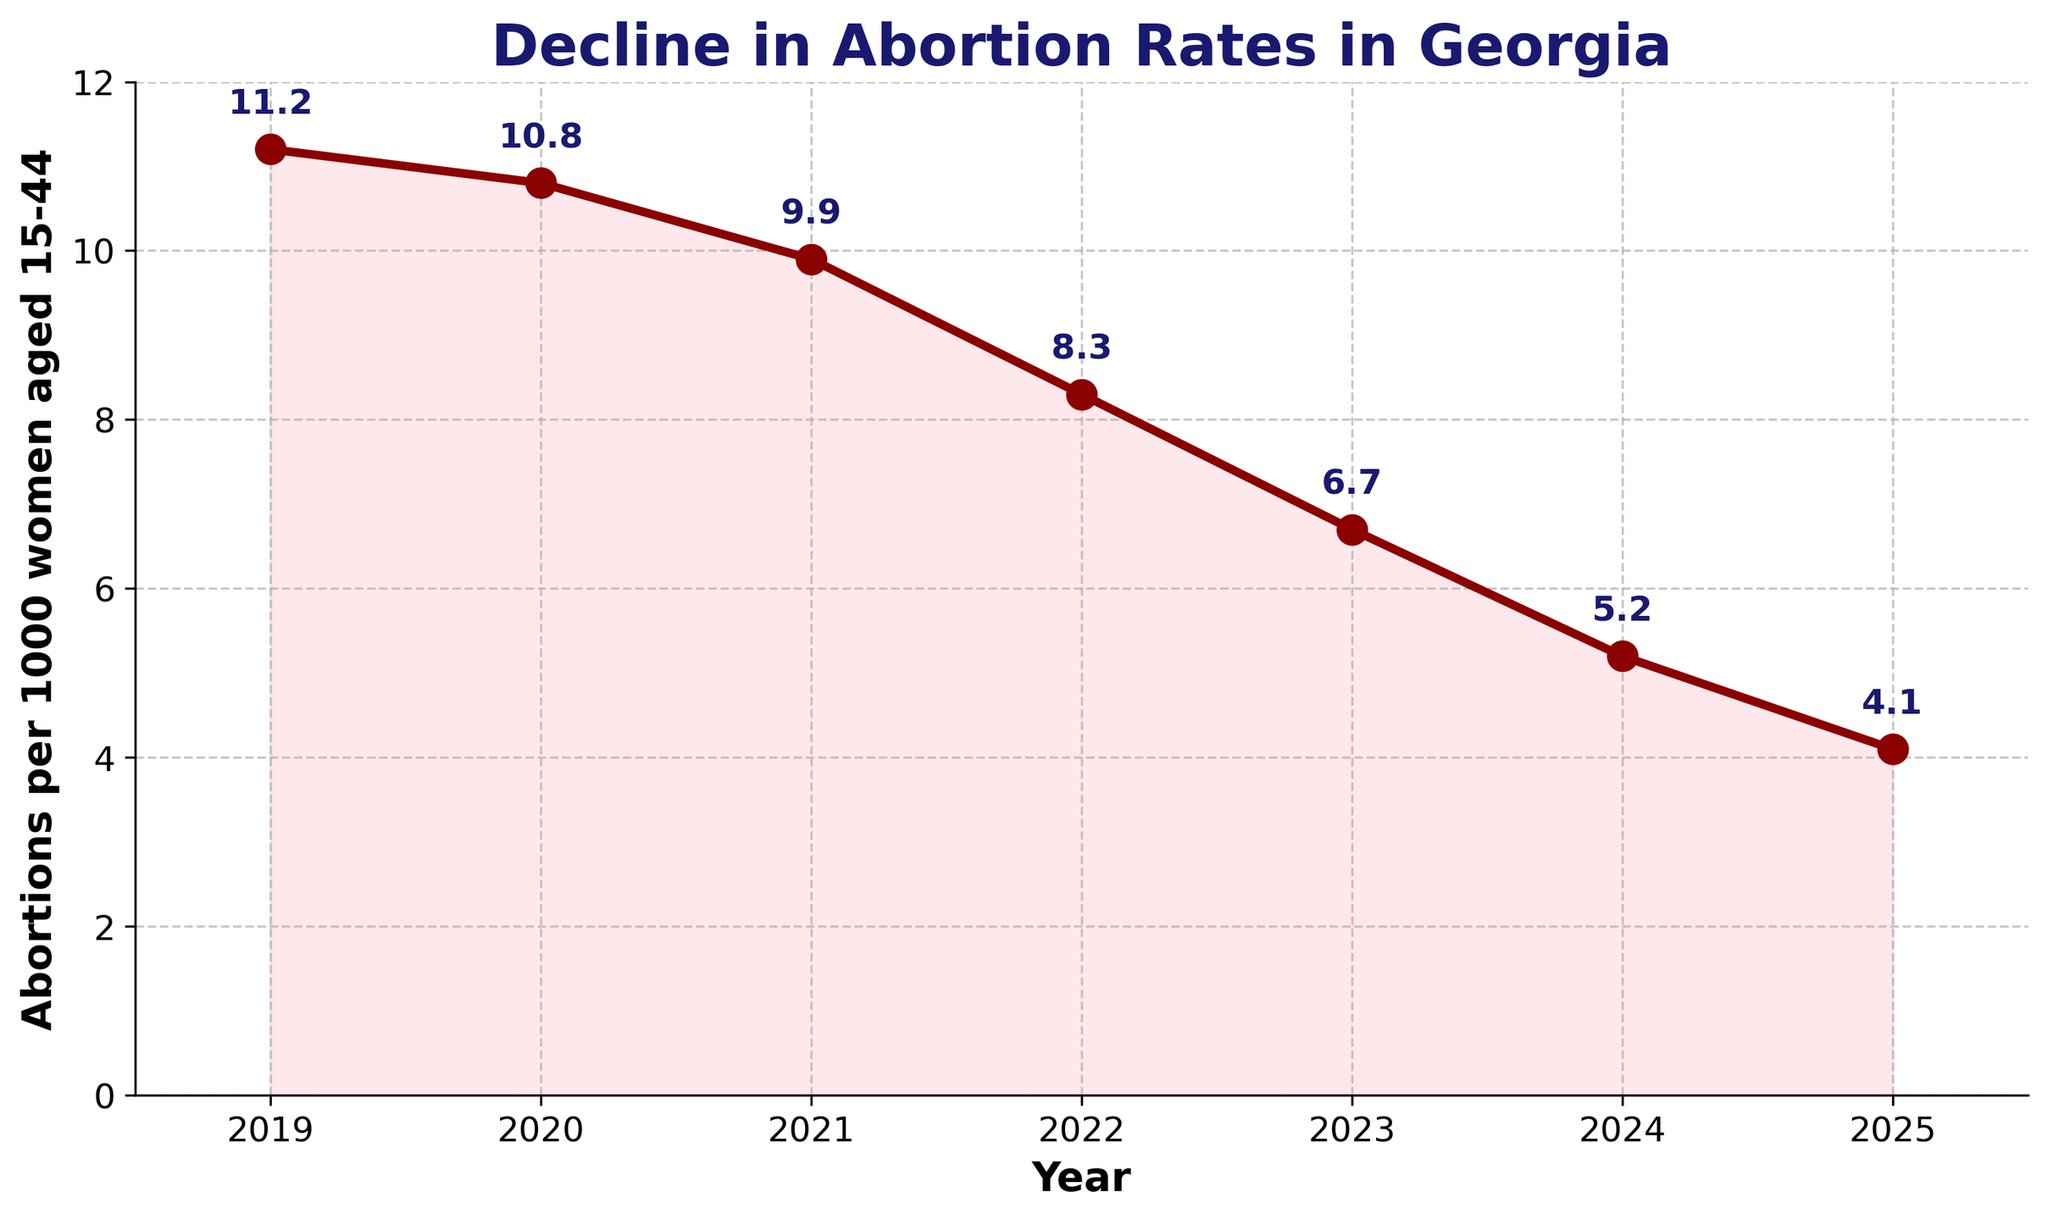What is the trend of abortion rates from 2019 to 2025? The abortion rates show a consistent decline each year from 11.2 in 2019 to 4.1 in 2025.
Answer: Consistent decline What was the abortion rate in 2023? The figure shows a data point for 2023 with an annotated rate of 6.7 abortions per 1000 women aged 15-44.
Answer: 6.7 Between which consecutive years was the largest drop in abortion rates observed? By observing the annotations on the line chart, the largest drop is between 2019 and 2020, where it declines from 11.2 to 10.8.
Answer: Between 2019 and 2020 Compare the abortion rates of 2020 and 2022. Which year had a higher rate and by how much? The abortion rate in 2020 was 10.8 and in 2022 it was 8.3. The 2020 rate is higher by 10.8 - 8.3 = 2.5.
Answer: 2020 by 2.5 What is the overall percentage decline in abortion rates from 2019 to 2025? To find the percentage decline: ((11.2 - 4.1) / 11.2) * 100 = 63.39%.
Answer: 63.39% What is the color of the line plotting the abortion rates? Observing the plot, the line plotting the abortion rates is colored red.
Answer: Red What is the significance of the shaded area under the line plot? The shaded area under the line plot highlights the declining trend in abortion rates over the years. It visually emphasizes the reduction.
Answer: Emphasizes declining trend Was there any year between 2019 and 2025 when the abortion rate increased compared to the previous year? Checking each year's data points and annotations, the abortion rate decreases every year without any increase.
Answer: No, it always decreased What is the average abortion rate over the period from 2019 to 2025? The average abortion rate is calculated by summing the rates (11.2 + 10.8 + 9.9 + 8.3 + 6.7 + 5.2 + 4.1) and dividing by the number of years (7). (11.2 + 10.8 + 9.9 + 8.3 + 6.7 + 5.2 + 4.1) / 7 = 8.031
Answer: 8.031 